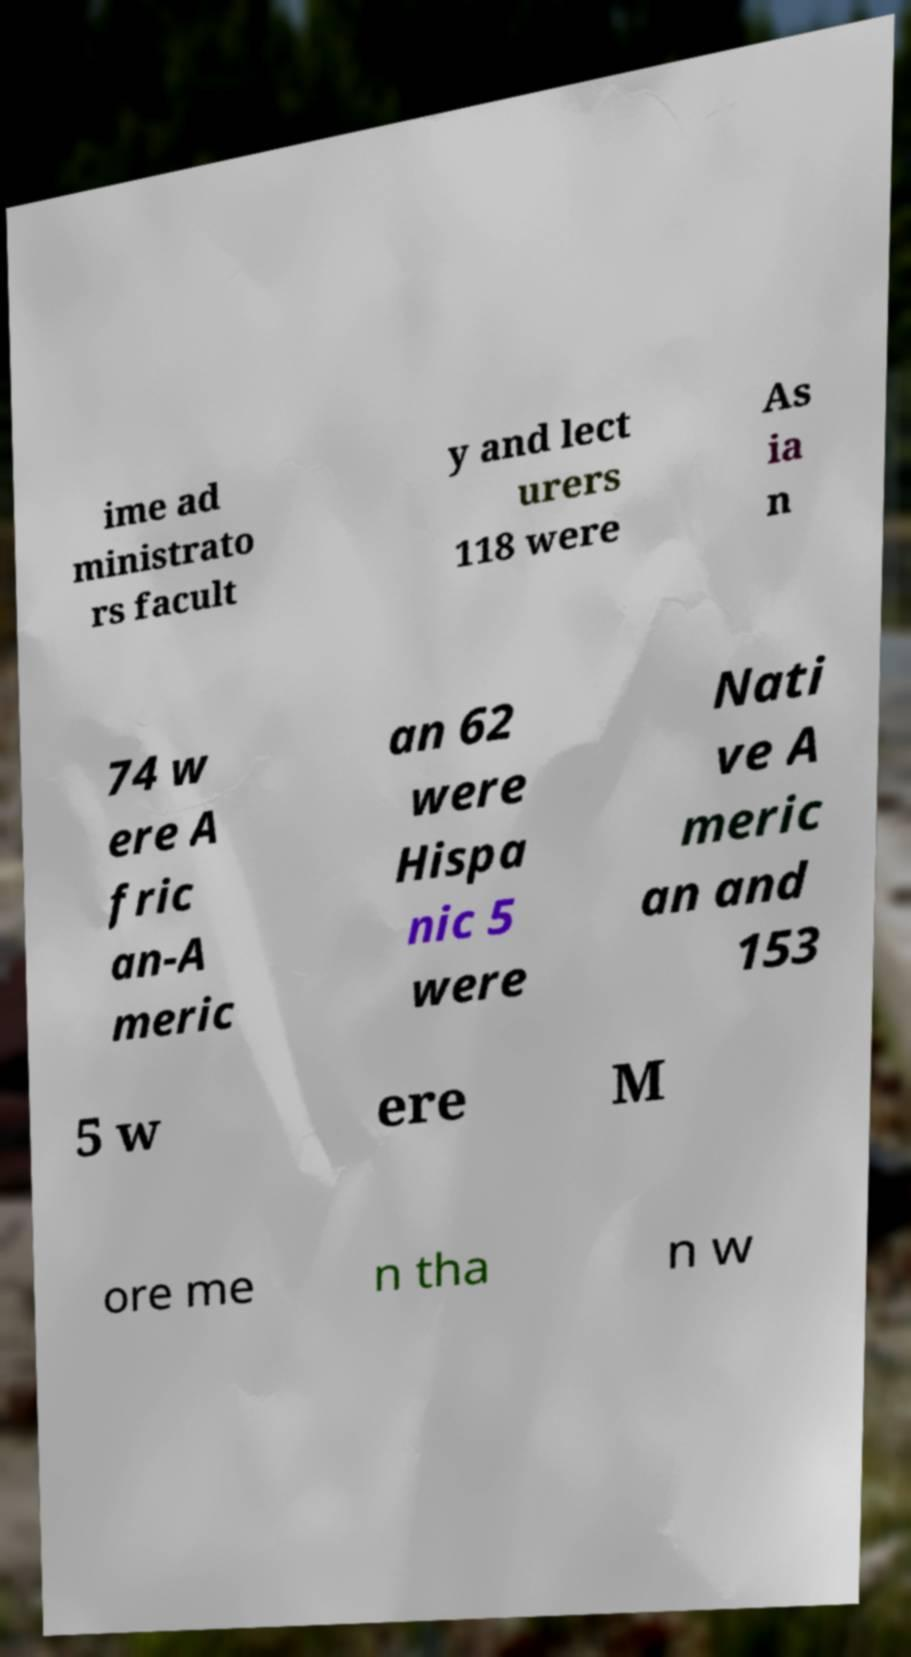Please identify and transcribe the text found in this image. ime ad ministrato rs facult y and lect urers 118 were As ia n 74 w ere A fric an-A meric an 62 were Hispa nic 5 were Nati ve A meric an and 153 5 w ere M ore me n tha n w 